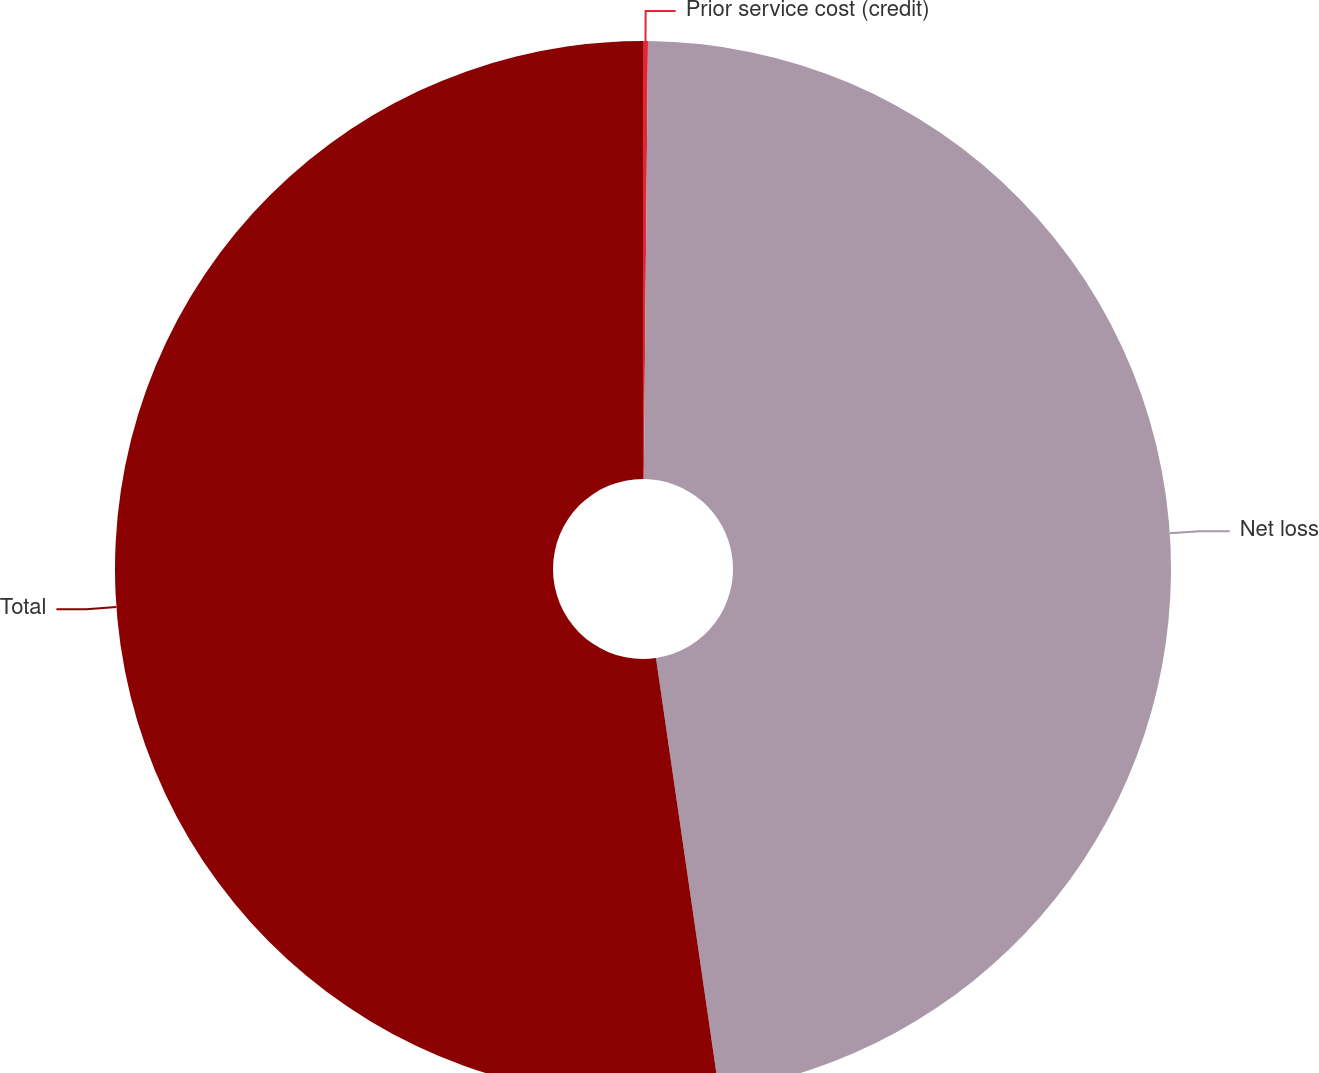Convert chart. <chart><loc_0><loc_0><loc_500><loc_500><pie_chart><fcel>Prior service cost (credit)<fcel>Net loss<fcel>Total<nl><fcel>0.15%<fcel>47.55%<fcel>52.3%<nl></chart> 